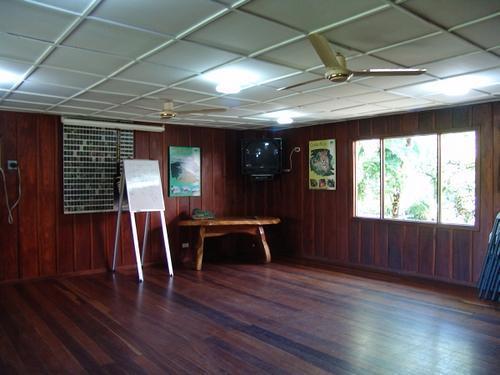How many fans are in the room?
Give a very brief answer. 2. 